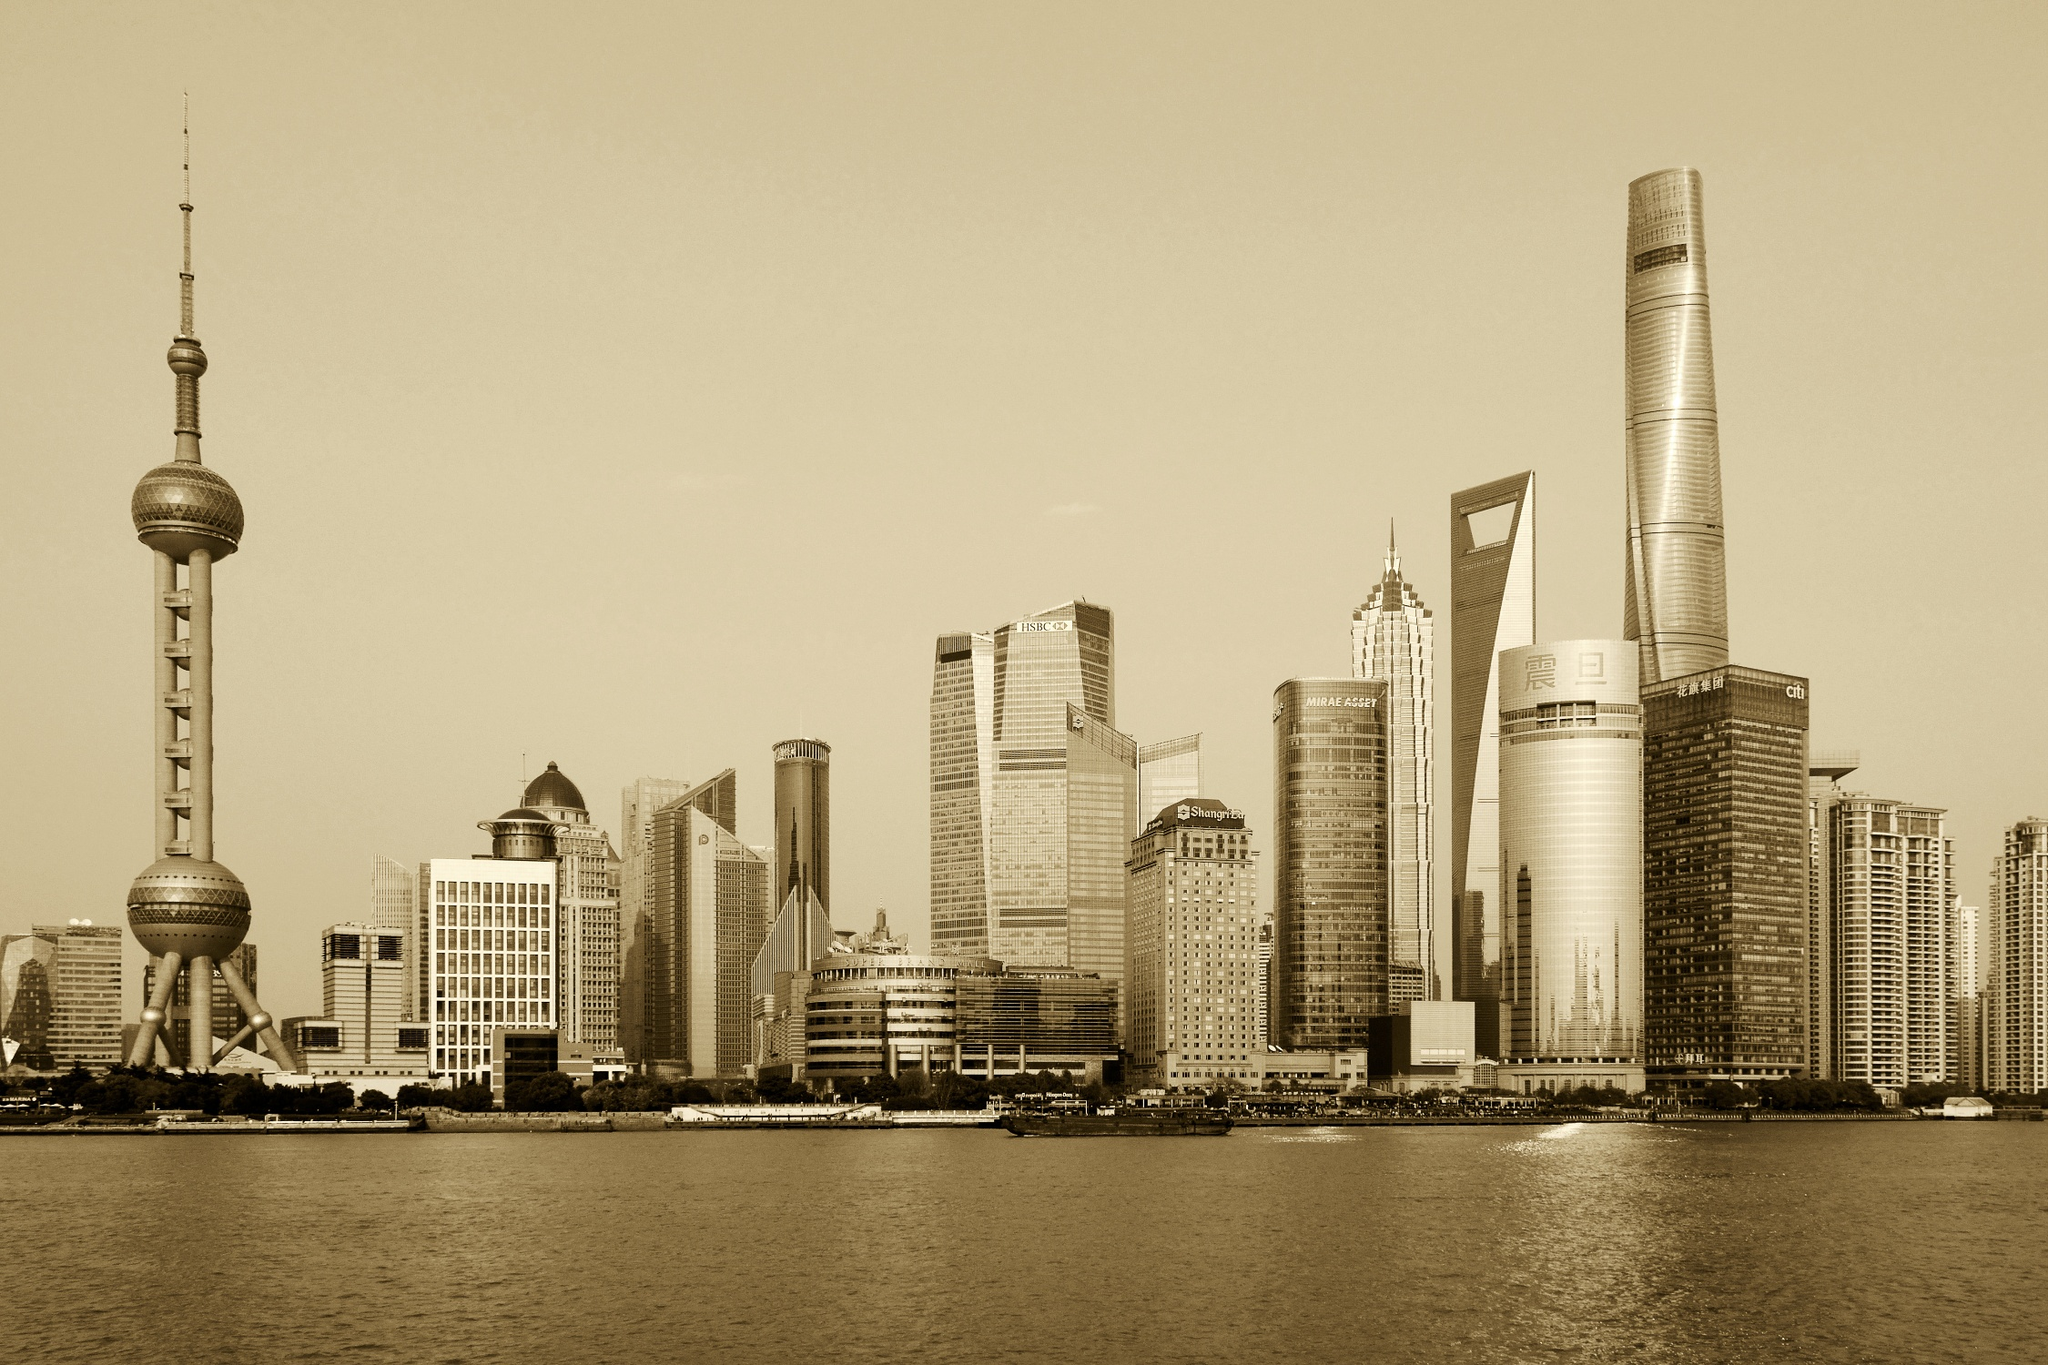What architectural styles can be seen in this image? The image displays a variety of architectural styles. The Oriental Pearl Tower combines futuristic design with traditional Chinese aesthetics, symbolized by the spheres and stilt-like structure. The Jin Mao Tower is an example of modernist architecture with inspiration from traditional Chinese pagodas, evident in its tiered structure. The Shanghai World Financial Center stands out with its minimalist, post-modern design, characterized by the large trapezoidal hole near the top. The Shanghai Tower follows a sleek, twisted form, embodying high-tech, sustainable design principles. Can you explain the cultural significance of these buildings? Each building in the image carries cultural significance. The Oriental Pearl Tower, for instance, is a symbol of China's modernization and technological advancement. Its design fuses contemporary engineering with historic symbolism, and it has become a cultural icon representing Shanghai’s rapid growth. The Jin Mao Tower, with its pagoda-like design, reflects China's architectural heritage while embracing modern functionality. The Shanghai World Financial Center and Shanghai Tower signify the city's global financial influence and dedication to sustainable and forward-thinking development. Together, these structures represent Shanghai's blend of tradition and innovation, symbolizing its role as a bridge between the past and the future.  Imagine that this skyline has animated features, what kind of story would it tell? Let’s imagine the skyline comes to life at night, where each building has a personality and their own tales to tell. The Oriental Pearl Tower, acting as the wise elder, shares stories of Shanghai's ancient past, its evolution, and the dreams held by the city’s inhabitants. The Jin Mao Tower, with its elegant lights, narrates the tales of craftsmen and architects who meticulously designed the city’s structures, blending art and utility. The Shanghai World Financial Center, illuminated with vibrant hues, represents the hustle and bustle of the city's financial dealings, sharing secrets of global trades and economic triumphs. The Shanghai Tower, standing tall and spinning gently, speaks of innovation, sustainability, and the future aspirations of Shanghai. Meanwhile, reflections in the Huangpu River dance to these tales, creating a harmonious symphony of light and shadow, merging past, present, and future into a mesmerizing nocturnal spectacle. 